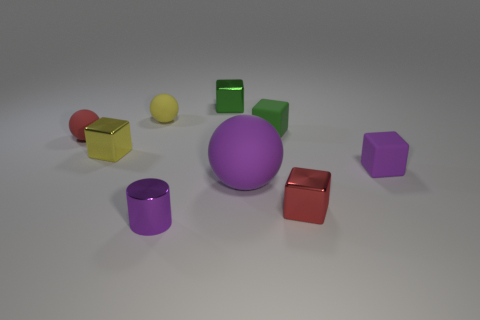Subtract all tiny green cubes. How many cubes are left? 3 Subtract all green balls. How many green cubes are left? 2 Subtract all purple balls. How many balls are left? 2 Subtract 2 cubes. How many cubes are left? 3 Subtract all cylinders. How many objects are left? 8 Subtract all yellow cubes. Subtract all blue cylinders. How many cubes are left? 4 Subtract all large cyan metallic blocks. Subtract all small purple cubes. How many objects are left? 8 Add 4 tiny metallic cylinders. How many tiny metallic cylinders are left? 5 Add 1 red rubber objects. How many red rubber objects exist? 2 Subtract 1 yellow balls. How many objects are left? 8 